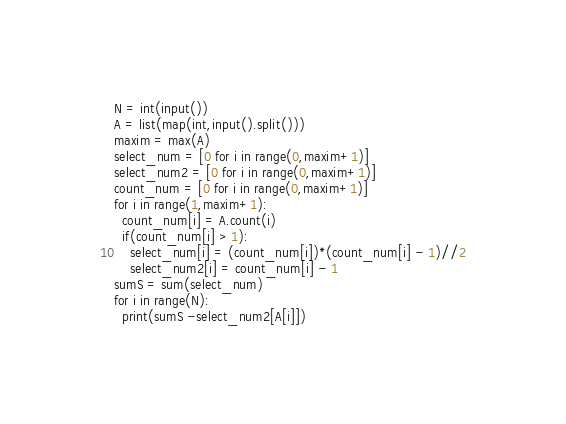Convert code to text. <code><loc_0><loc_0><loc_500><loc_500><_Python_>N = int(input())
A = list(map(int,input().split()))
maxim = max(A)
select_num = [0 for i in range(0,maxim+1)]
select_num2 = [0 for i in range(0,maxim+1)]
count_num = [0 for i in range(0,maxim+1)]
for i in range(1,maxim+1):
  count_num[i] = A.count(i)
  if(count_num[i] > 1):
    select_num[i] = (count_num[i])*(count_num[i] - 1)//2
    select_num2[i] = count_num[i] - 1
sumS = sum(select_num)
for i in range(N):
  print(sumS -select_num2[A[i]])</code> 